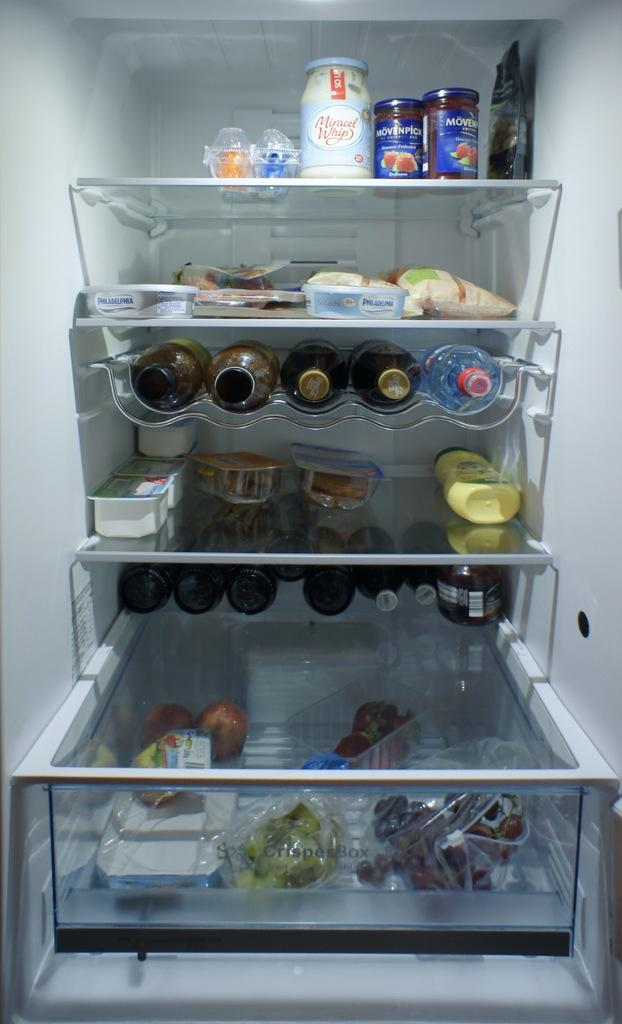What type of space is shown in the image? The image shows an inside view of a refrigerator. What features are present in the refrigerator? There are compartments in the refrigerator. What types of items can be seen inside the refrigerator? There are bottles, food items, fruits, and boxes in the refrigerator. Can you see a tree growing inside the refrigerator in the image? No, there is no tree growing inside the refrigerator in the image. 